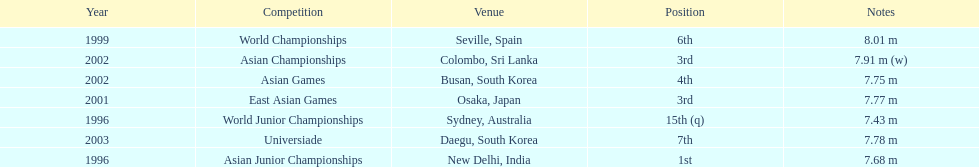Tell me the only venue in spain. Seville, Spain. 